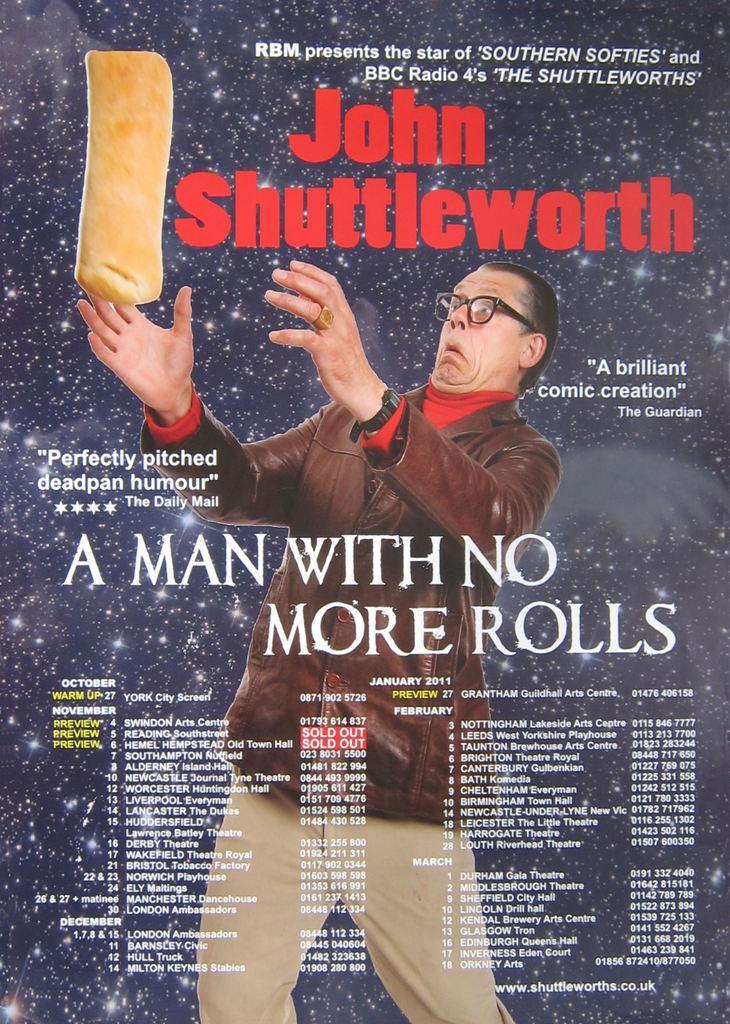Could you give a brief overview of what you see in this image? In this picture I can see there is a man holding object and there is something written on it. This is a cover page of the book. 